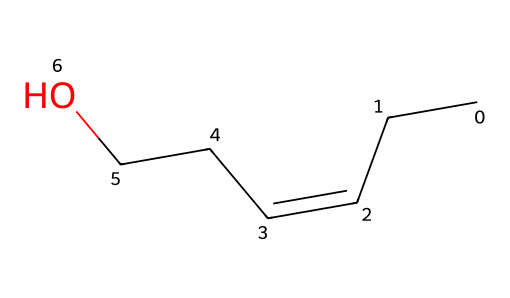What is the main functional group present in this compound? The SMILES representation indicates a hydroxyl group (-OH) due to the "CCO" section, where "O" is the oxygen indicating alcohol.
Answer: hydroxyl group How many carbon atoms are in this compound? The SMILES notation shows five "C" characters, each representing a carbon atom, thus there are 5 carbons in total.
Answer: 5 Does this compound have any double bonds? The "/C=C/" part of the SMILES indicates that there is a double bond between two carbon atoms in this structure.
Answer: yes What type of chemical is represented here? The structure features a hydroxyl group and a specific carbon arrangement indicative of an alcohol, often used in flavors and fragrances.
Answer: alcohol What characteristic aroma does this compound likely produce? Given its structural similarity to components found in grass, it is likely to produce a fresh, grassy aroma reminiscent of tennis court turf.
Answer: grassy aroma What is the saturation level of this compound? The presence of a double bond (from "/C=C/") indicates that the compound is unsaturated because it contains fewer hydrogen atoms than a fully saturated structure.
Answer: unsaturated 